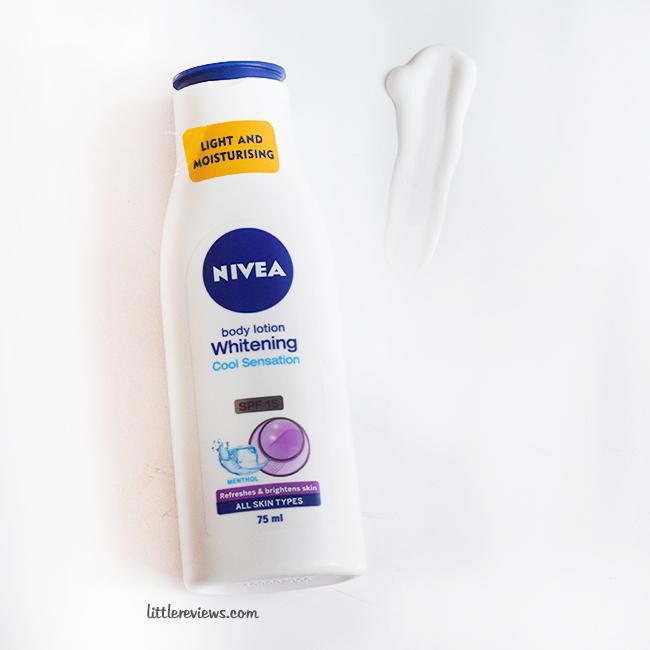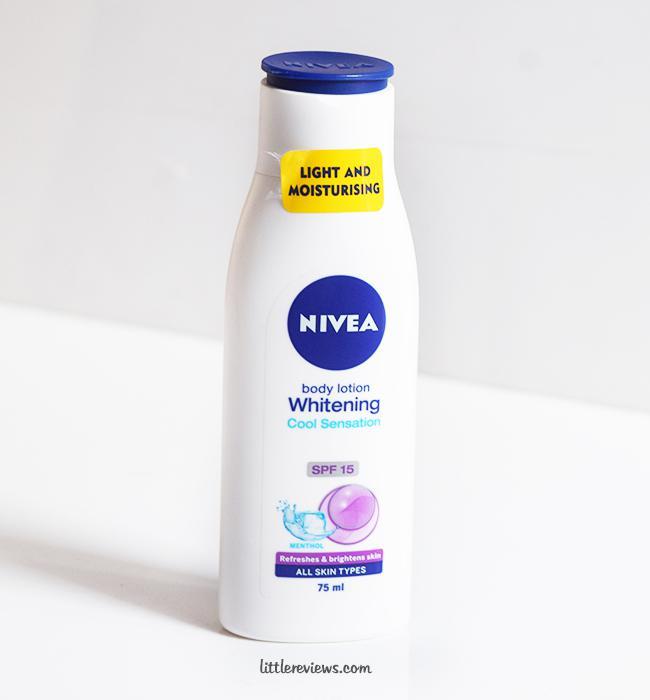The first image is the image on the left, the second image is the image on the right. Analyze the images presented: Is the assertion "There is a torn sticker on the bottle in the image on the left." valid? Answer yes or no. No. The first image is the image on the left, the second image is the image on the right. Considering the images on both sides, is "All lotion bottles have dark blue caps." valid? Answer yes or no. Yes. 